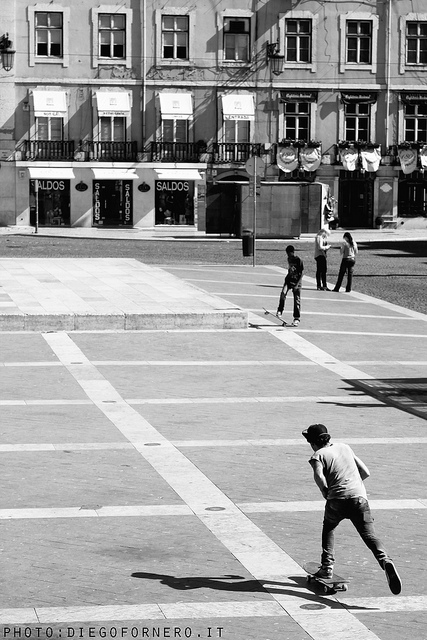Identify the text displayed in this image. TALDOS SALDOS SALDOS SALDOS PHOTO DIEGOFORNERO IT 